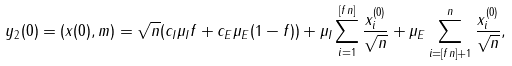<formula> <loc_0><loc_0><loc_500><loc_500>y _ { 2 } ( 0 ) = ( x ( 0 ) , m ) = \sqrt { n } ( c _ { I } \mu _ { I } f + c _ { E } \mu _ { E } ( 1 - f ) ) + \mu _ { I } \sum _ { i = 1 } ^ { [ f n ] } \frac { x ^ { ( 0 ) } _ { i } } { \sqrt { n } } + \mu _ { E } \sum _ { i = [ f n ] + 1 } ^ { n } \frac { x ^ { ( 0 ) } _ { i } } { \sqrt { n } } ,</formula> 